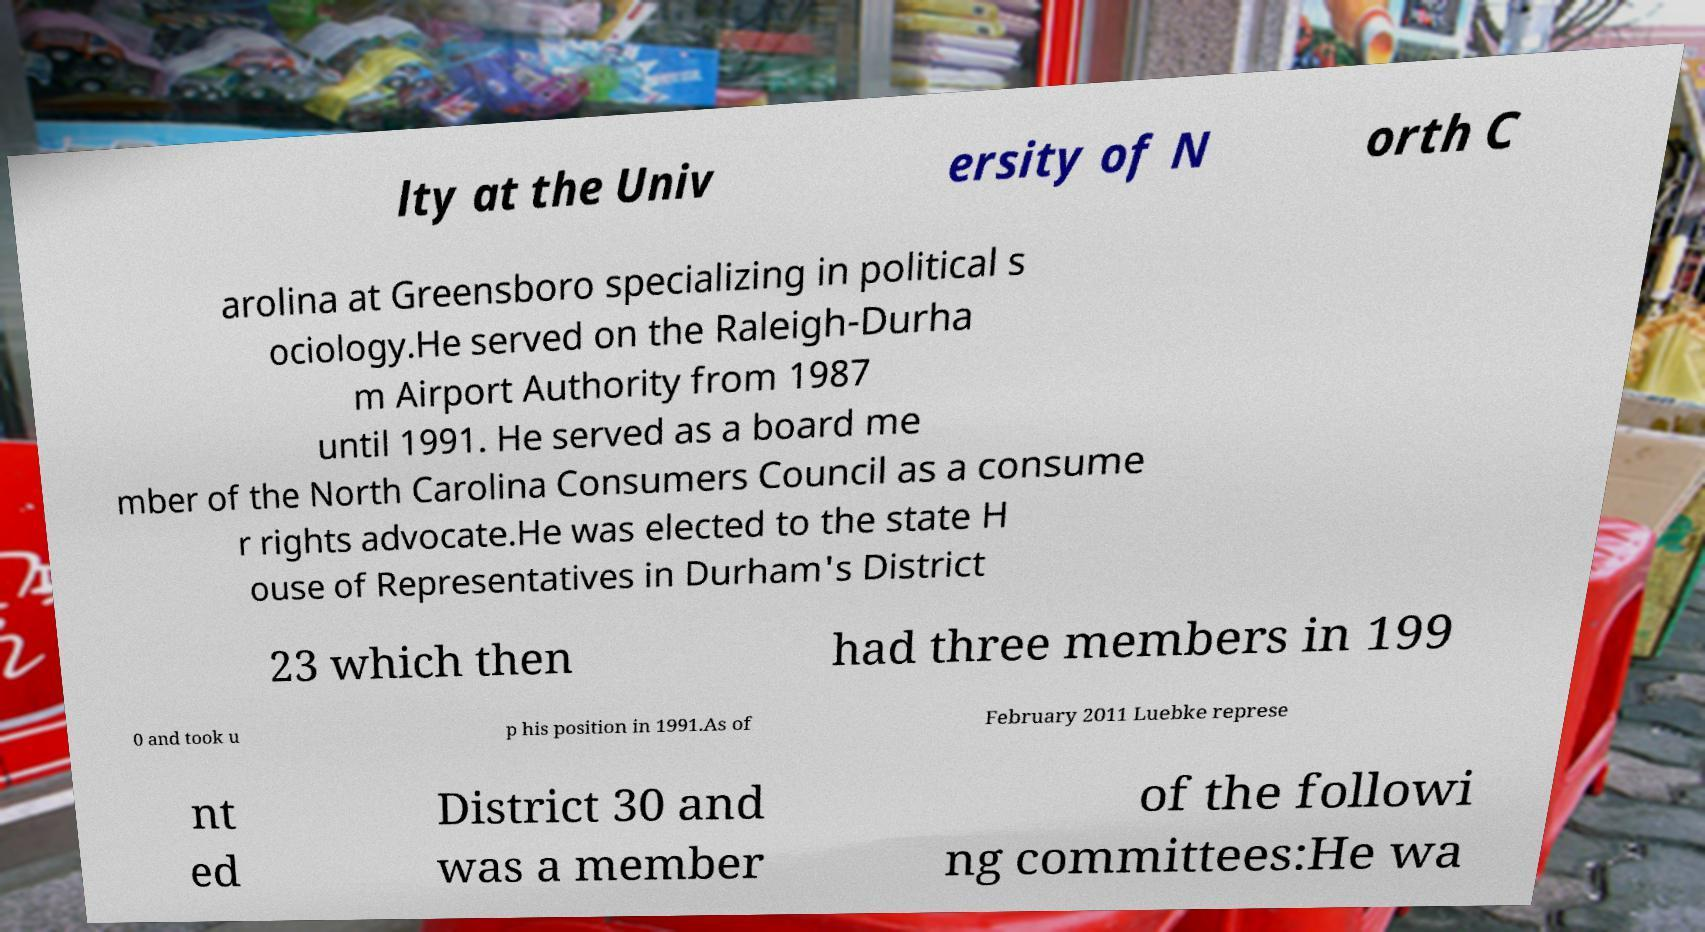I need the written content from this picture converted into text. Can you do that? lty at the Univ ersity of N orth C arolina at Greensboro specializing in political s ociology.He served on the Raleigh-Durha m Airport Authority from 1987 until 1991. He served as a board me mber of the North Carolina Consumers Council as a consume r rights advocate.He was elected to the state H ouse of Representatives in Durham's District 23 which then had three members in 199 0 and took u p his position in 1991.As of February 2011 Luebke represe nt ed District 30 and was a member of the followi ng committees:He wa 